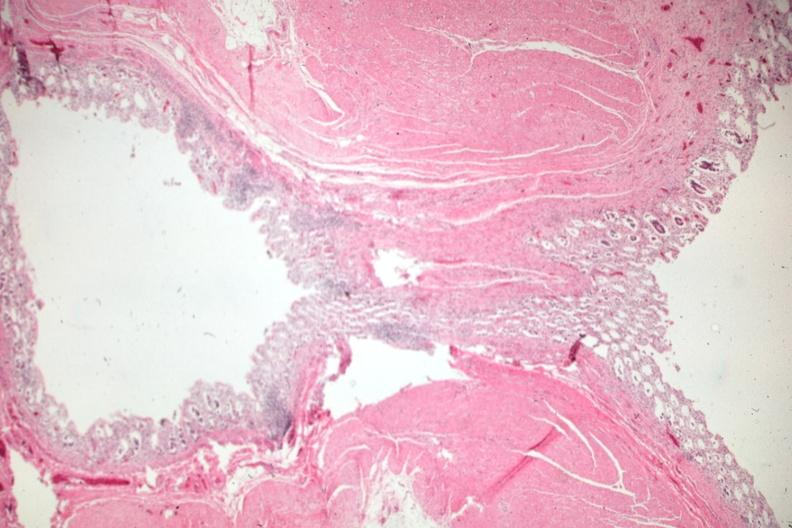s colon present?
Answer the question using a single word or phrase. Yes 